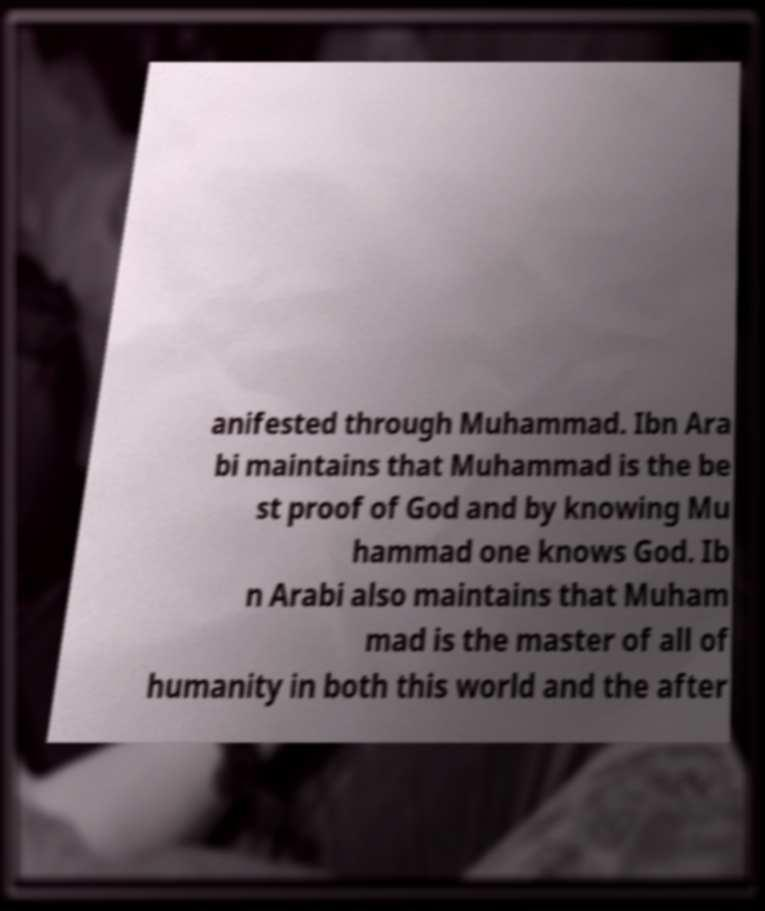For documentation purposes, I need the text within this image transcribed. Could you provide that? anifested through Muhammad. Ibn Ara bi maintains that Muhammad is the be st proof of God and by knowing Mu hammad one knows God. Ib n Arabi also maintains that Muham mad is the master of all of humanity in both this world and the after 